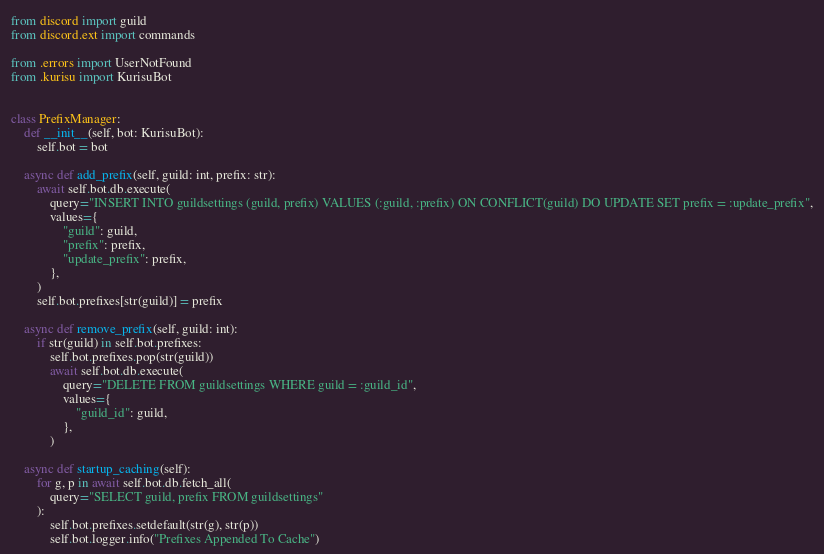Convert code to text. <code><loc_0><loc_0><loc_500><loc_500><_Python_>from discord import guild
from discord.ext import commands

from .errors import UserNotFound
from .kurisu import KurisuBot


class PrefixManager:
    def __init__(self, bot: KurisuBot):
        self.bot = bot

    async def add_prefix(self, guild: int, prefix: str):
        await self.bot.db.execute(
            query="INSERT INTO guildsettings (guild, prefix) VALUES (:guild, :prefix) ON CONFLICT(guild) DO UPDATE SET prefix = :update_prefix",
            values={
                "guild": guild,
                "prefix": prefix,
                "update_prefix": prefix,
            },
        )
        self.bot.prefixes[str(guild)] = prefix

    async def remove_prefix(self, guild: int):
        if str(guild) in self.bot.prefixes:
            self.bot.prefixes.pop(str(guild))
            await self.bot.db.execute(
                query="DELETE FROM guildsettings WHERE guild = :guild_id",
                values={
                    "guild_id": guild,
                },
            )

    async def startup_caching(self):
        for g, p in await self.bot.db.fetch_all(
            query="SELECT guild, prefix FROM guildsettings"
        ):
            self.bot.prefixes.setdefault(str(g), str(p))
            self.bot.logger.info("Prefixes Appended To Cache")

</code> 